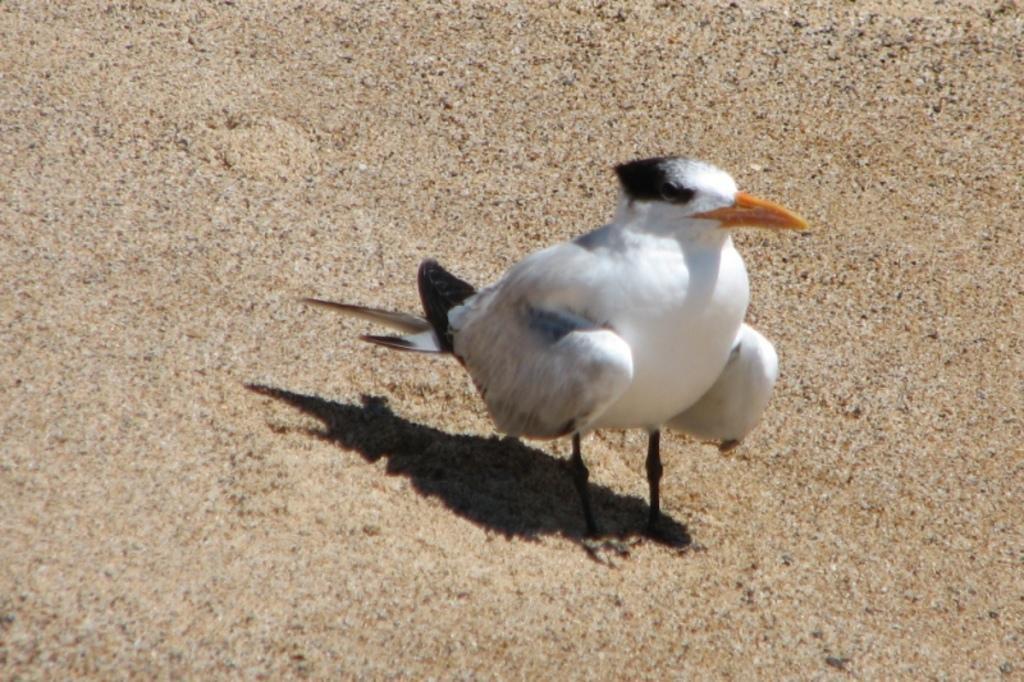Describe this image in one or two sentences. In this image there is a bird standing on the land. 